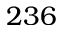Convert formula to latex. <formula><loc_0><loc_0><loc_500><loc_500>2 3 6</formula> 